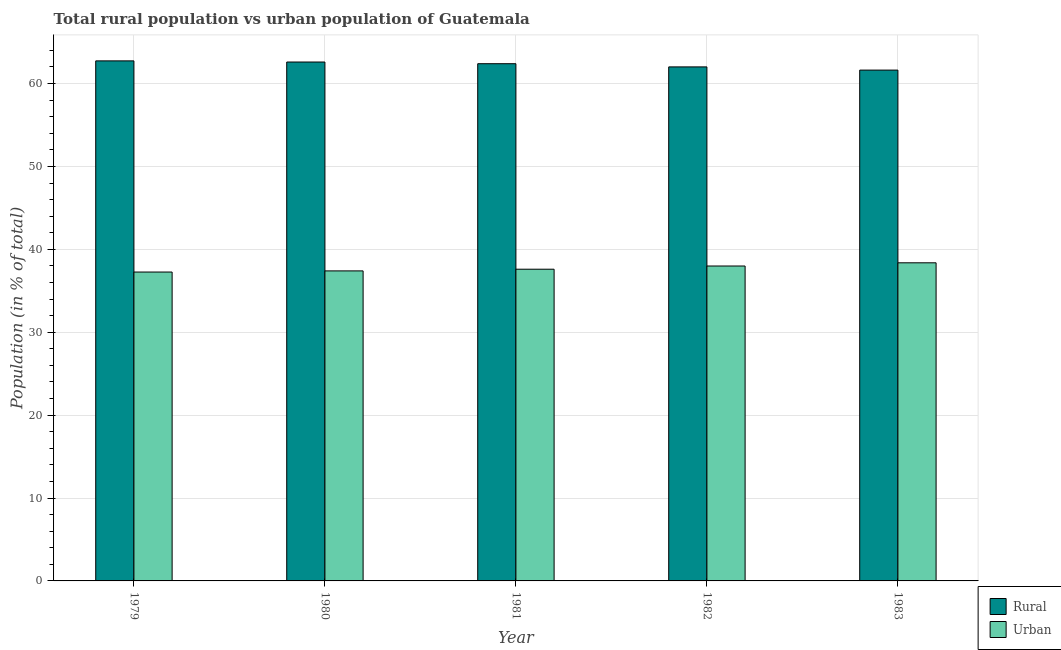How many different coloured bars are there?
Provide a succinct answer. 2. How many groups of bars are there?
Keep it short and to the point. 5. How many bars are there on the 3rd tick from the left?
Provide a succinct answer. 2. How many bars are there on the 2nd tick from the right?
Offer a terse response. 2. In how many cases, is the number of bars for a given year not equal to the number of legend labels?
Your answer should be compact. 0. What is the rural population in 1980?
Your response must be concise. 62.6. Across all years, what is the maximum rural population?
Offer a terse response. 62.74. Across all years, what is the minimum urban population?
Offer a very short reply. 37.26. In which year was the urban population minimum?
Your answer should be compact. 1979. What is the total rural population in the graph?
Your response must be concise. 311.37. What is the difference between the rural population in 1980 and that in 1982?
Provide a short and direct response. 0.59. What is the difference between the rural population in 1981 and the urban population in 1979?
Your answer should be very brief. -0.34. What is the average rural population per year?
Your response must be concise. 62.27. In the year 1982, what is the difference between the rural population and urban population?
Ensure brevity in your answer.  0. What is the ratio of the rural population in 1980 to that in 1981?
Make the answer very short. 1. What is the difference between the highest and the second highest urban population?
Your answer should be compact. 0.39. What is the difference between the highest and the lowest rural population?
Your answer should be very brief. 1.11. In how many years, is the rural population greater than the average rural population taken over all years?
Give a very brief answer. 3. Is the sum of the urban population in 1979 and 1983 greater than the maximum rural population across all years?
Offer a very short reply. Yes. What does the 2nd bar from the left in 1981 represents?
Offer a very short reply. Urban. What does the 1st bar from the right in 1979 represents?
Your answer should be very brief. Urban. How many years are there in the graph?
Your answer should be very brief. 5. Are the values on the major ticks of Y-axis written in scientific E-notation?
Provide a succinct answer. No. Does the graph contain any zero values?
Make the answer very short. No. Where does the legend appear in the graph?
Offer a terse response. Bottom right. How are the legend labels stacked?
Ensure brevity in your answer.  Vertical. What is the title of the graph?
Ensure brevity in your answer.  Total rural population vs urban population of Guatemala. Does "Constant 2005 US$" appear as one of the legend labels in the graph?
Keep it short and to the point. No. What is the label or title of the X-axis?
Your response must be concise. Year. What is the label or title of the Y-axis?
Offer a terse response. Population (in % of total). What is the Population (in % of total) of Rural in 1979?
Give a very brief answer. 62.74. What is the Population (in % of total) in Urban in 1979?
Offer a terse response. 37.26. What is the Population (in % of total) of Rural in 1980?
Keep it short and to the point. 62.6. What is the Population (in % of total) in Urban in 1980?
Offer a terse response. 37.4. What is the Population (in % of total) of Rural in 1981?
Provide a short and direct response. 62.4. What is the Population (in % of total) of Urban in 1981?
Provide a succinct answer. 37.6. What is the Population (in % of total) of Rural in 1982?
Your response must be concise. 62.01. What is the Population (in % of total) of Urban in 1982?
Ensure brevity in your answer.  37.99. What is the Population (in % of total) of Rural in 1983?
Your answer should be compact. 61.62. What is the Population (in % of total) in Urban in 1983?
Provide a succinct answer. 38.38. Across all years, what is the maximum Population (in % of total) of Rural?
Ensure brevity in your answer.  62.74. Across all years, what is the maximum Population (in % of total) of Urban?
Make the answer very short. 38.38. Across all years, what is the minimum Population (in % of total) in Rural?
Your response must be concise. 61.62. Across all years, what is the minimum Population (in % of total) of Urban?
Provide a succinct answer. 37.26. What is the total Population (in % of total) in Rural in the graph?
Keep it short and to the point. 311.37. What is the total Population (in % of total) in Urban in the graph?
Provide a succinct answer. 188.63. What is the difference between the Population (in % of total) of Rural in 1979 and that in 1980?
Make the answer very short. 0.14. What is the difference between the Population (in % of total) of Urban in 1979 and that in 1980?
Keep it short and to the point. -0.14. What is the difference between the Population (in % of total) of Rural in 1979 and that in 1981?
Make the answer very short. 0.34. What is the difference between the Population (in % of total) in Urban in 1979 and that in 1981?
Provide a succinct answer. -0.34. What is the difference between the Population (in % of total) of Rural in 1979 and that in 1982?
Provide a short and direct response. 0.73. What is the difference between the Population (in % of total) in Urban in 1979 and that in 1982?
Offer a very short reply. -0.73. What is the difference between the Population (in % of total) in Rural in 1979 and that in 1983?
Offer a very short reply. 1.11. What is the difference between the Population (in % of total) of Urban in 1979 and that in 1983?
Your answer should be compact. -1.11. What is the difference between the Population (in % of total) in Rural in 1980 and that in 1981?
Ensure brevity in your answer.  0.2. What is the difference between the Population (in % of total) of Urban in 1980 and that in 1981?
Your answer should be compact. -0.2. What is the difference between the Population (in % of total) in Rural in 1980 and that in 1982?
Provide a succinct answer. 0.59. What is the difference between the Population (in % of total) of Urban in 1980 and that in 1982?
Provide a short and direct response. -0.59. What is the difference between the Population (in % of total) of Urban in 1980 and that in 1983?
Provide a succinct answer. -0.97. What is the difference between the Population (in % of total) of Rural in 1981 and that in 1982?
Your answer should be very brief. 0.39. What is the difference between the Population (in % of total) of Urban in 1981 and that in 1982?
Ensure brevity in your answer.  -0.39. What is the difference between the Population (in % of total) in Rural in 1981 and that in 1983?
Give a very brief answer. 0.77. What is the difference between the Population (in % of total) of Urban in 1981 and that in 1983?
Offer a very short reply. -0.77. What is the difference between the Population (in % of total) of Rural in 1982 and that in 1983?
Your answer should be compact. 0.39. What is the difference between the Population (in % of total) of Urban in 1982 and that in 1983?
Provide a short and direct response. -0.39. What is the difference between the Population (in % of total) of Rural in 1979 and the Population (in % of total) of Urban in 1980?
Ensure brevity in your answer.  25.34. What is the difference between the Population (in % of total) in Rural in 1979 and the Population (in % of total) in Urban in 1981?
Ensure brevity in your answer.  25.13. What is the difference between the Population (in % of total) in Rural in 1979 and the Population (in % of total) in Urban in 1982?
Offer a terse response. 24.75. What is the difference between the Population (in % of total) in Rural in 1979 and the Population (in % of total) in Urban in 1983?
Make the answer very short. 24.36. What is the difference between the Population (in % of total) in Rural in 1980 and the Population (in % of total) in Urban in 1981?
Ensure brevity in your answer.  24.99. What is the difference between the Population (in % of total) of Rural in 1980 and the Population (in % of total) of Urban in 1982?
Provide a succinct answer. 24.61. What is the difference between the Population (in % of total) of Rural in 1980 and the Population (in % of total) of Urban in 1983?
Offer a very short reply. 24.22. What is the difference between the Population (in % of total) of Rural in 1981 and the Population (in % of total) of Urban in 1982?
Offer a terse response. 24.41. What is the difference between the Population (in % of total) of Rural in 1981 and the Population (in % of total) of Urban in 1983?
Offer a very short reply. 24.02. What is the difference between the Population (in % of total) in Rural in 1982 and the Population (in % of total) in Urban in 1983?
Offer a very short reply. 23.63. What is the average Population (in % of total) of Rural per year?
Give a very brief answer. 62.27. What is the average Population (in % of total) of Urban per year?
Ensure brevity in your answer.  37.73. In the year 1979, what is the difference between the Population (in % of total) of Rural and Population (in % of total) of Urban?
Offer a terse response. 25.47. In the year 1980, what is the difference between the Population (in % of total) of Rural and Population (in % of total) of Urban?
Give a very brief answer. 25.2. In the year 1981, what is the difference between the Population (in % of total) of Rural and Population (in % of total) of Urban?
Give a very brief answer. 24.79. In the year 1982, what is the difference between the Population (in % of total) of Rural and Population (in % of total) of Urban?
Offer a terse response. 24.02. In the year 1983, what is the difference between the Population (in % of total) of Rural and Population (in % of total) of Urban?
Provide a short and direct response. 23.25. What is the ratio of the Population (in % of total) in Rural in 1979 to that in 1981?
Your response must be concise. 1.01. What is the ratio of the Population (in % of total) in Urban in 1979 to that in 1981?
Keep it short and to the point. 0.99. What is the ratio of the Population (in % of total) in Rural in 1979 to that in 1982?
Your answer should be very brief. 1.01. What is the ratio of the Population (in % of total) of Urban in 1979 to that in 1982?
Provide a short and direct response. 0.98. What is the ratio of the Population (in % of total) of Rural in 1979 to that in 1983?
Give a very brief answer. 1.02. What is the ratio of the Population (in % of total) of Urban in 1979 to that in 1983?
Offer a very short reply. 0.97. What is the ratio of the Population (in % of total) of Urban in 1980 to that in 1981?
Make the answer very short. 0.99. What is the ratio of the Population (in % of total) in Rural in 1980 to that in 1982?
Provide a short and direct response. 1.01. What is the ratio of the Population (in % of total) in Urban in 1980 to that in 1982?
Your answer should be very brief. 0.98. What is the ratio of the Population (in % of total) in Rural in 1980 to that in 1983?
Offer a terse response. 1.02. What is the ratio of the Population (in % of total) of Urban in 1980 to that in 1983?
Provide a succinct answer. 0.97. What is the ratio of the Population (in % of total) of Urban in 1981 to that in 1982?
Ensure brevity in your answer.  0.99. What is the ratio of the Population (in % of total) in Rural in 1981 to that in 1983?
Your answer should be very brief. 1.01. What is the ratio of the Population (in % of total) in Urban in 1981 to that in 1983?
Your response must be concise. 0.98. What is the difference between the highest and the second highest Population (in % of total) in Rural?
Your response must be concise. 0.14. What is the difference between the highest and the second highest Population (in % of total) in Urban?
Give a very brief answer. 0.39. What is the difference between the highest and the lowest Population (in % of total) of Rural?
Offer a very short reply. 1.11. What is the difference between the highest and the lowest Population (in % of total) of Urban?
Give a very brief answer. 1.11. 